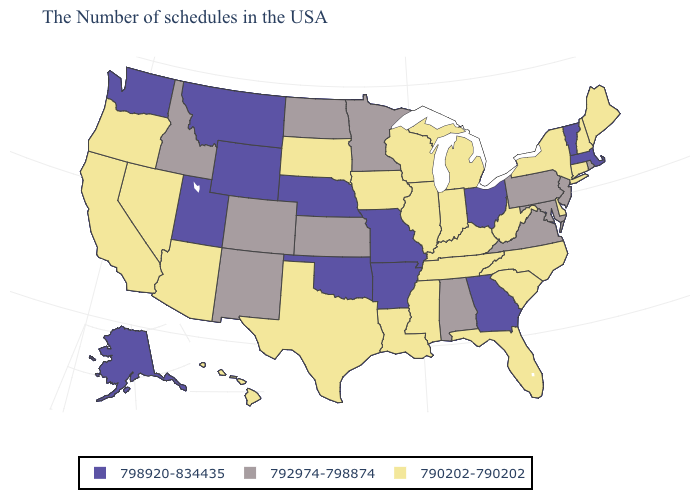Name the states that have a value in the range 790202-790202?
Give a very brief answer. Maine, New Hampshire, Connecticut, New York, Delaware, North Carolina, South Carolina, West Virginia, Florida, Michigan, Kentucky, Indiana, Tennessee, Wisconsin, Illinois, Mississippi, Louisiana, Iowa, Texas, South Dakota, Arizona, Nevada, California, Oregon, Hawaii. What is the value of Florida?
Keep it brief. 790202-790202. Among the states that border Virginia , does Maryland have the highest value?
Answer briefly. Yes. Does Pennsylvania have the lowest value in the Northeast?
Short answer required. No. How many symbols are there in the legend?
Short answer required. 3. What is the value of Kentucky?
Concise answer only. 790202-790202. Does Arkansas have the highest value in the South?
Be succinct. Yes. What is the highest value in states that border Idaho?
Write a very short answer. 798920-834435. Name the states that have a value in the range 798920-834435?
Write a very short answer. Massachusetts, Vermont, Ohio, Georgia, Missouri, Arkansas, Nebraska, Oklahoma, Wyoming, Utah, Montana, Washington, Alaska. Does Oklahoma have the highest value in the USA?
Quick response, please. Yes. What is the value of Georgia?
Quick response, please. 798920-834435. What is the highest value in the USA?
Be succinct. 798920-834435. What is the value of Arizona?
Concise answer only. 790202-790202. Does Alaska have the highest value in the West?
Quick response, please. Yes. 